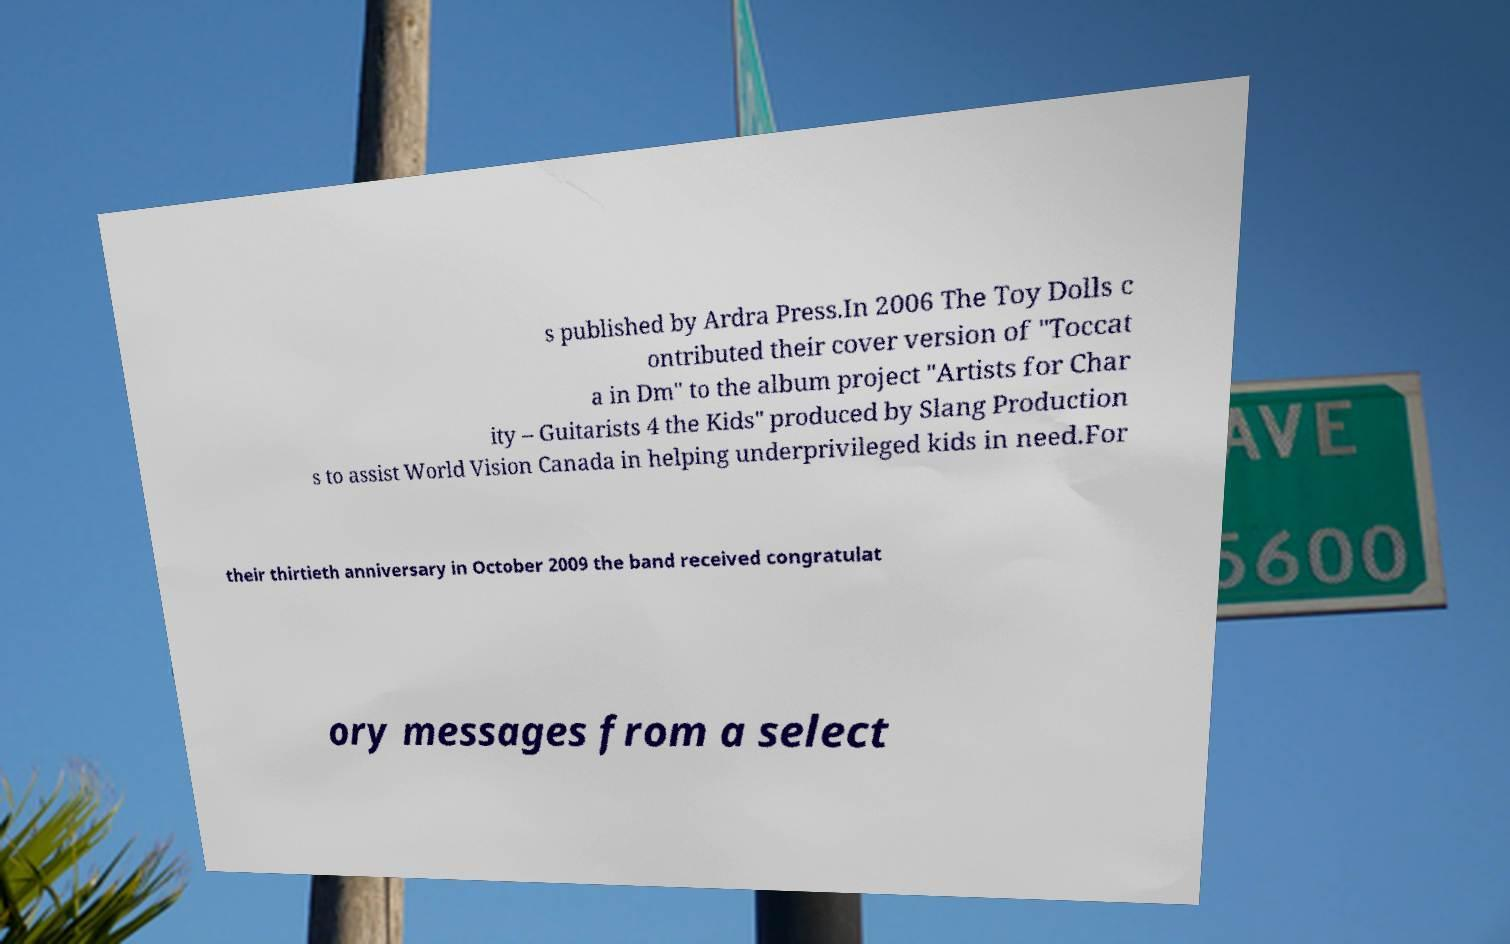I need the written content from this picture converted into text. Can you do that? s published by Ardra Press.In 2006 The Toy Dolls c ontributed their cover version of "Toccat a in Dm" to the album project "Artists for Char ity – Guitarists 4 the Kids" produced by Slang Production s to assist World Vision Canada in helping underprivileged kids in need.For their thirtieth anniversary in October 2009 the band received congratulat ory messages from a select 